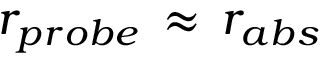<formula> <loc_0><loc_0><loc_500><loc_500>r _ { p r o b e } \, \approx \, r _ { a b s }</formula> 